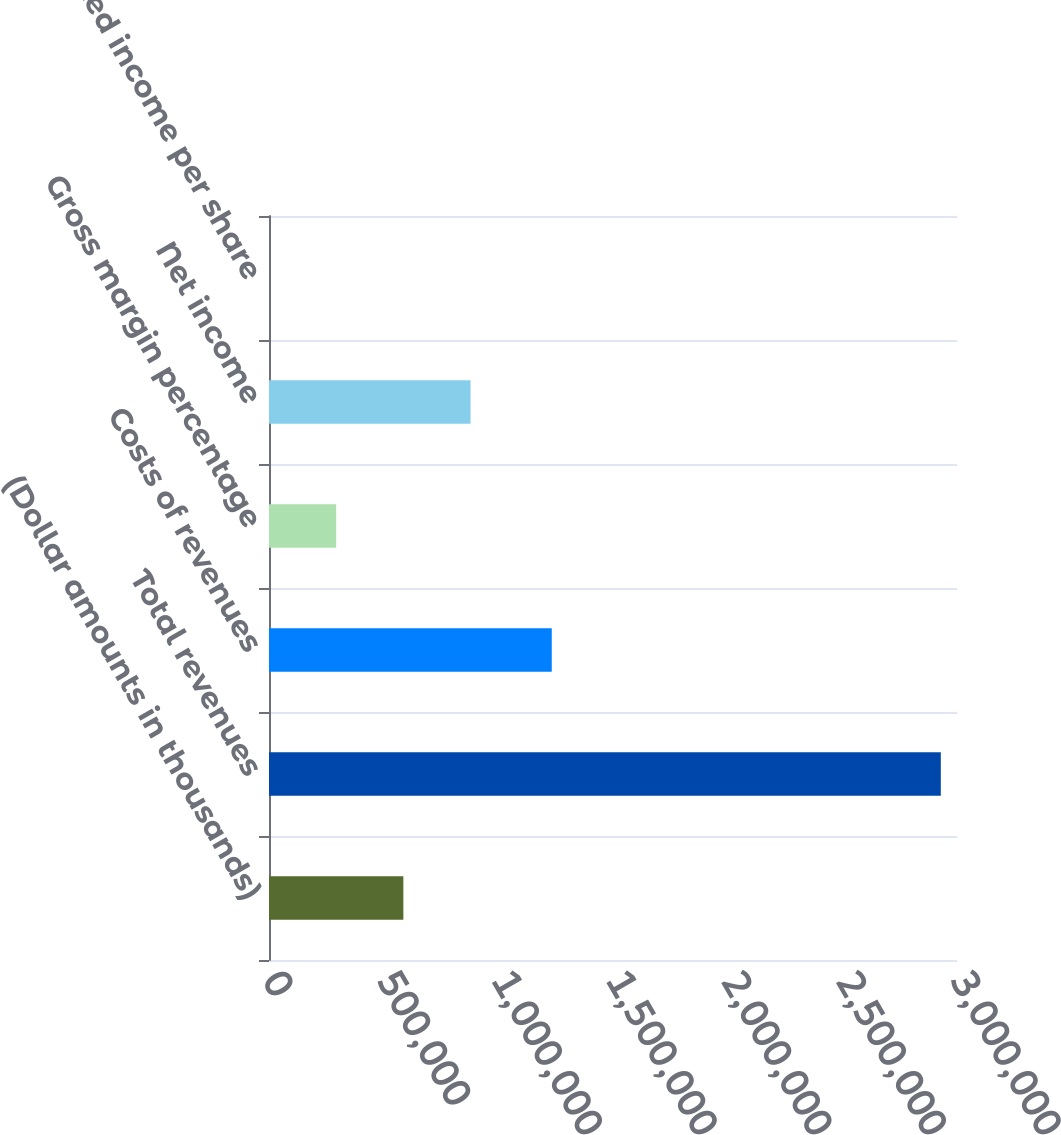Convert chart to OTSL. <chart><loc_0><loc_0><loc_500><loc_500><bar_chart><fcel>(Dollar amounts in thousands)<fcel>Total revenues<fcel>Costs of revenues<fcel>Gross margin percentage<fcel>Net income<fcel>Diluted income per share<nl><fcel>585884<fcel>2.92941e+06<fcel>1.23296e+06<fcel>292944<fcel>878825<fcel>3.47<nl></chart> 